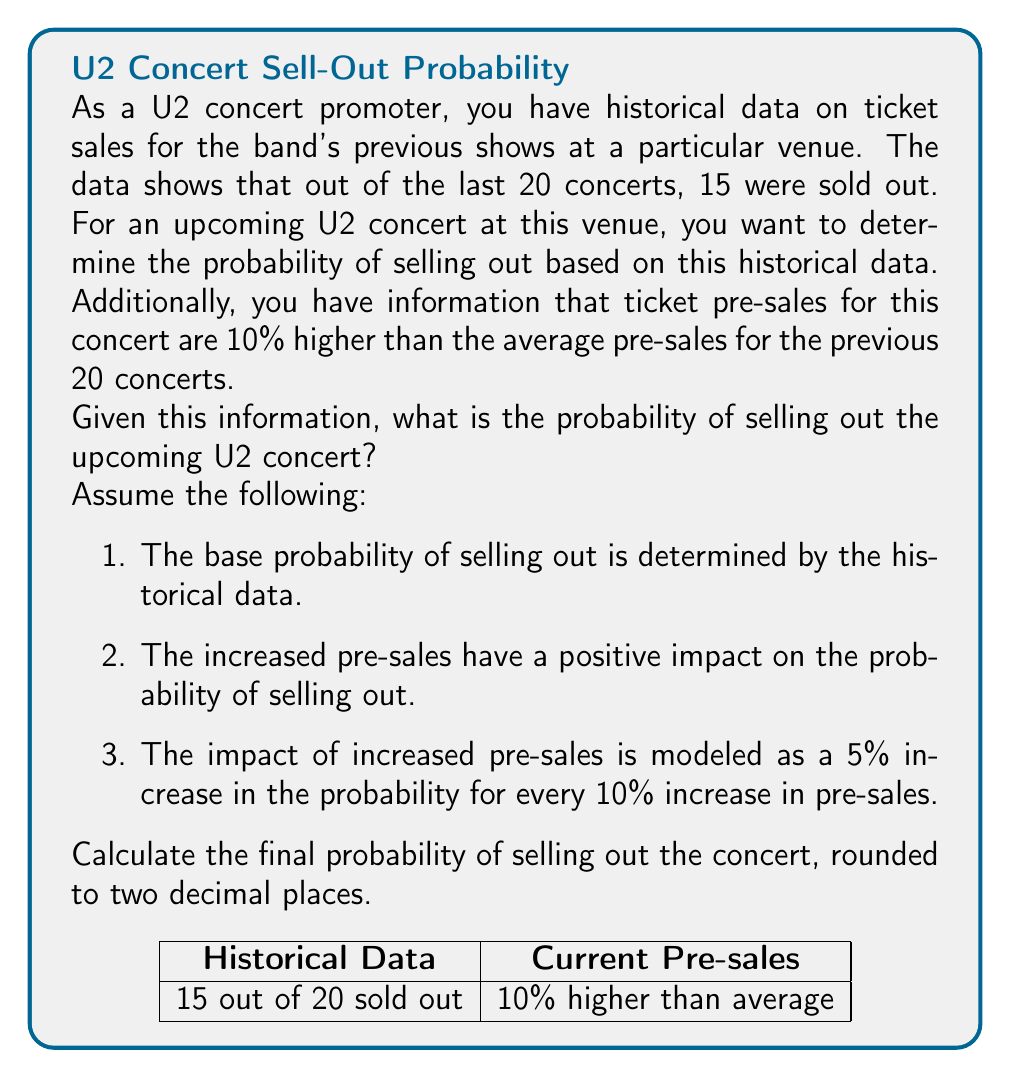Give your solution to this math problem. Let's approach this step-by-step:

1. Calculate the base probability of selling out using historical data:
   $$P(\text{sellout}) = \frac{\text{Number of sellouts}}{\text{Total number of concerts}} = \frac{15}{20} = 0.75$$

2. Calculate the impact of increased pre-sales:
   - Pre-sales are 10% higher than average
   - Each 10% increase in pre-sales increases the probability by 5%
   - So, we need to increase the base probability by 5%

3. Calculate the increase in probability:
   $$\text{Increase} = 0.75 \times 0.05 = 0.0375$$

4. Calculate the final probability:
   $$P(\text{sellout}_{\text{final}}) = P(\text{sellout}) + \text{Increase}$$
   $$P(\text{sellout}_{\text{final}}) = 0.75 + 0.0375 = 0.7875$$

5. Round the final probability to two decimal places:
   $$P(\text{sellout}_{\text{final}}) \approx 0.79$$

Therefore, the probability of selling out the upcoming U2 concert, considering the historical data and increased pre-sales, is approximately 0.79 or 79%.
Answer: 0.79 